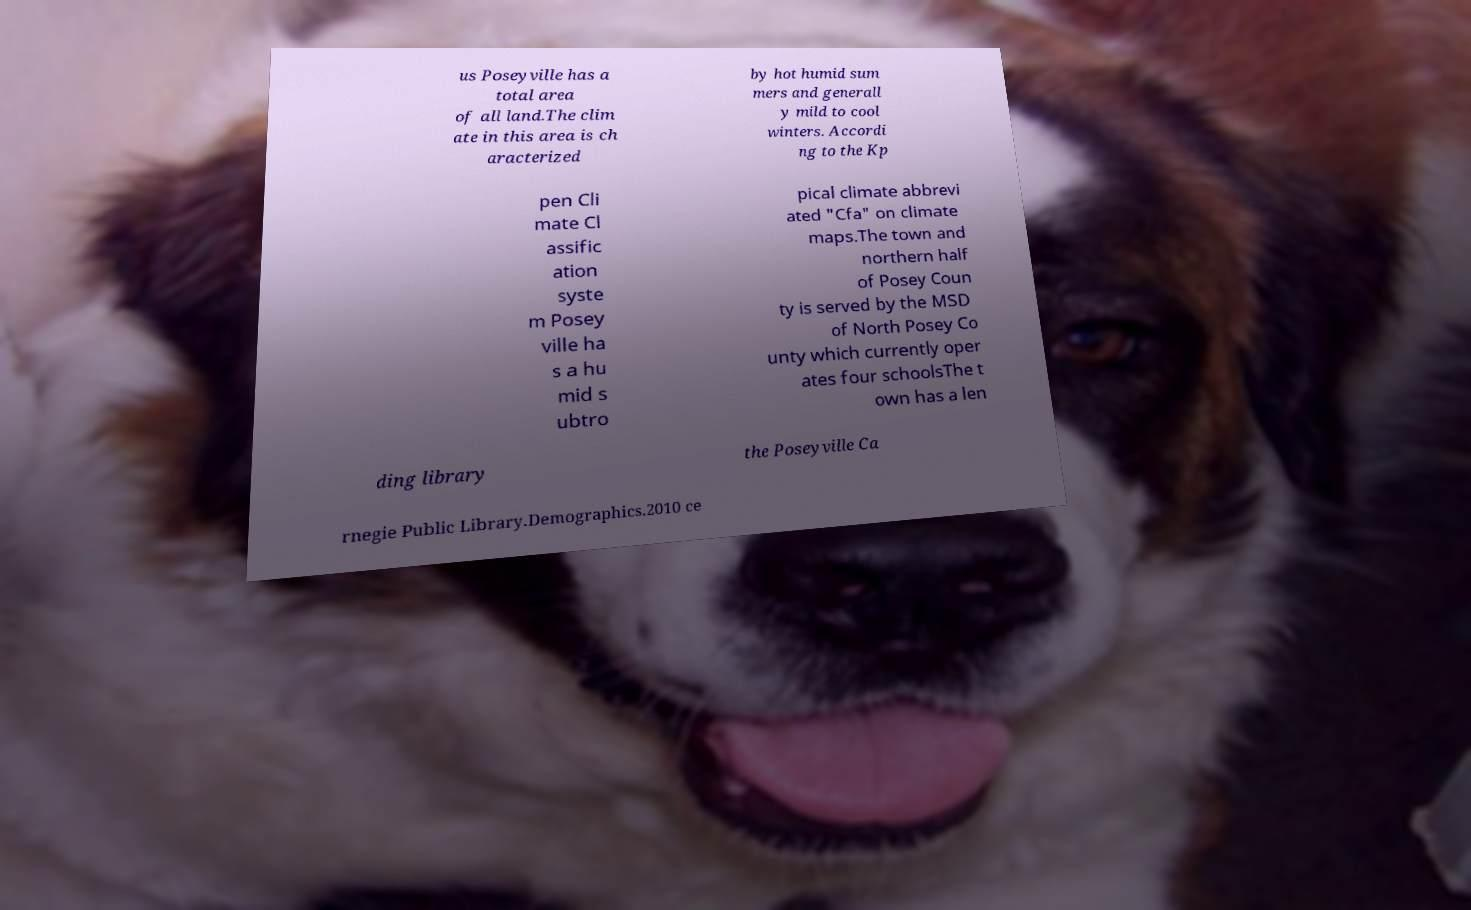There's text embedded in this image that I need extracted. Can you transcribe it verbatim? us Poseyville has a total area of all land.The clim ate in this area is ch aracterized by hot humid sum mers and generall y mild to cool winters. Accordi ng to the Kp pen Cli mate Cl assific ation syste m Posey ville ha s a hu mid s ubtro pical climate abbrevi ated "Cfa" on climate maps.The town and northern half of Posey Coun ty is served by the MSD of North Posey Co unty which currently oper ates four schoolsThe t own has a len ding library the Poseyville Ca rnegie Public Library.Demographics.2010 ce 